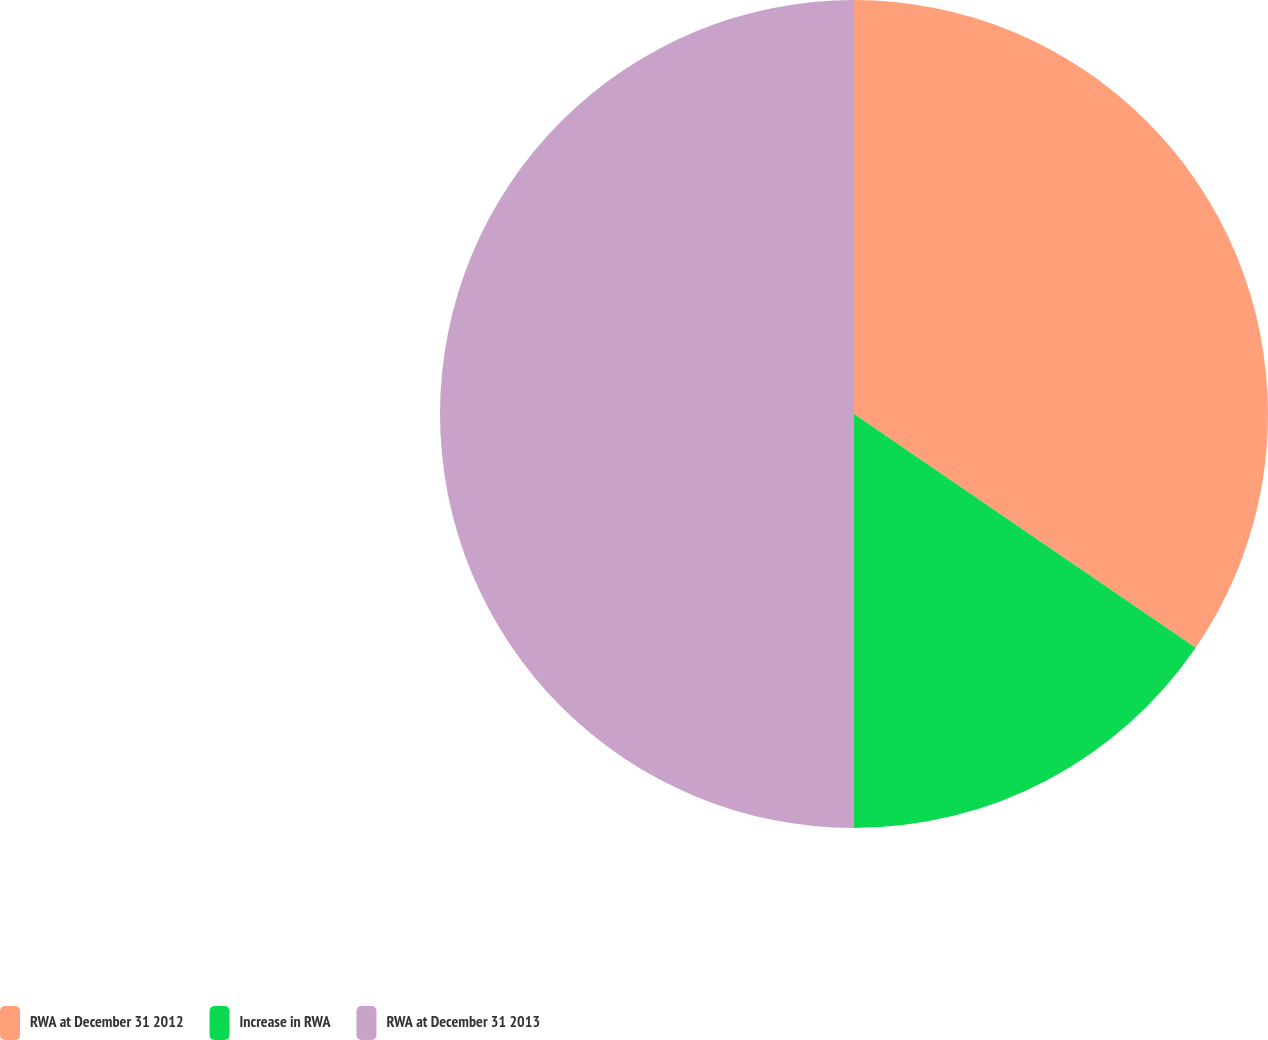Convert chart. <chart><loc_0><loc_0><loc_500><loc_500><pie_chart><fcel>RWA at December 31 2012<fcel>Increase in RWA<fcel>RWA at December 31 2013<nl><fcel>34.55%<fcel>15.45%<fcel>50.0%<nl></chart> 